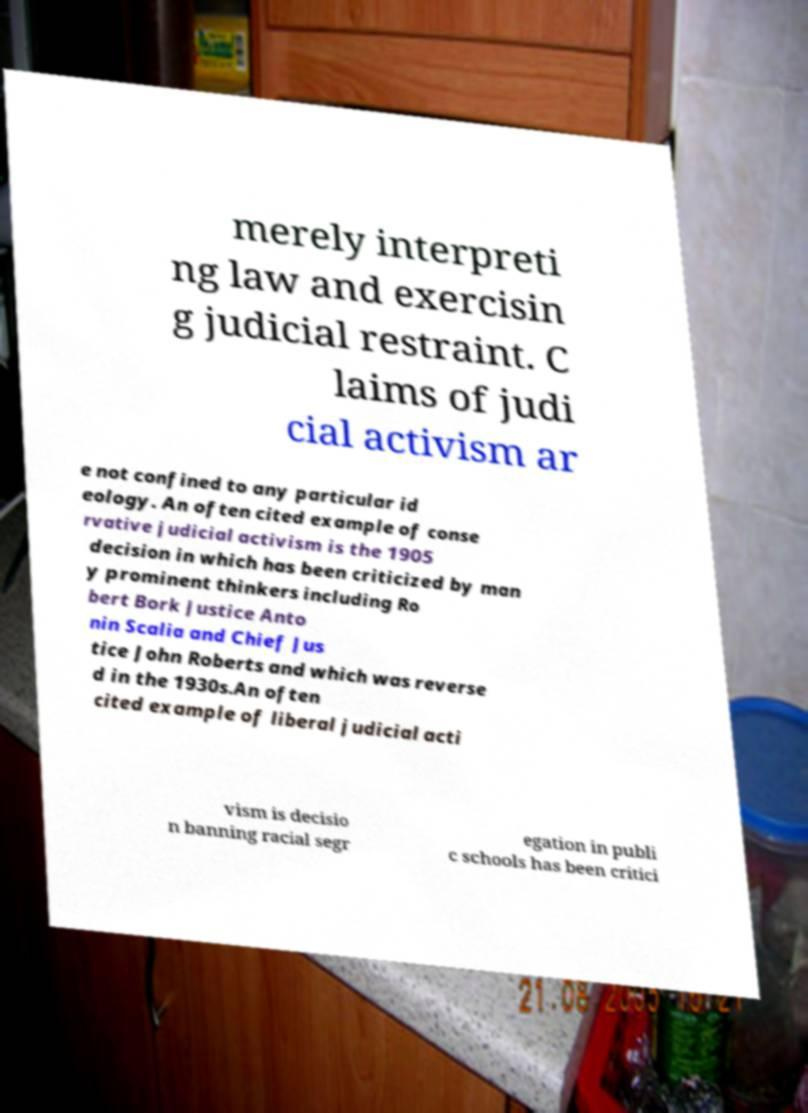There's text embedded in this image that I need extracted. Can you transcribe it verbatim? merely interpreti ng law and exercisin g judicial restraint. C laims of judi cial activism ar e not confined to any particular id eology. An often cited example of conse rvative judicial activism is the 1905 decision in which has been criticized by man y prominent thinkers including Ro bert Bork Justice Anto nin Scalia and Chief Jus tice John Roberts and which was reverse d in the 1930s.An often cited example of liberal judicial acti vism is decisio n banning racial segr egation in publi c schools has been critici 